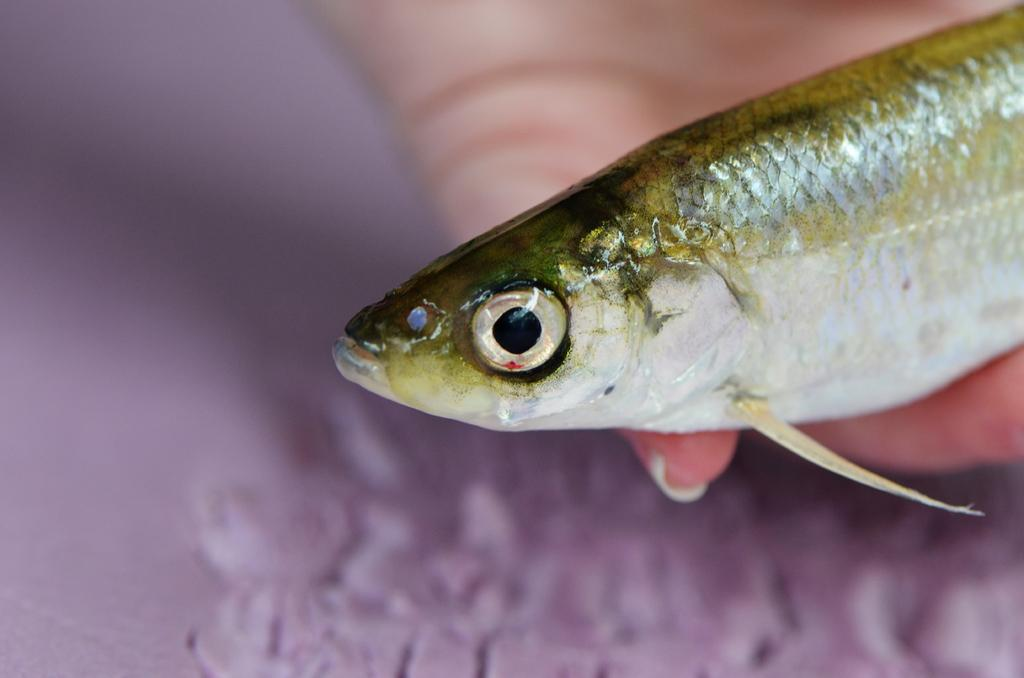What is the main subject of the image? The main subject of the image is a fish. Can you describe the perspective of the image? The image contains a close-up view of the fish. What is the fish's location in relation to a person? The fish is in someone's hand. How much profit did the person make from selling the alley in the image? There is no alley or mention of profit in the image; it features a close-up view of a fish in someone's hand. 